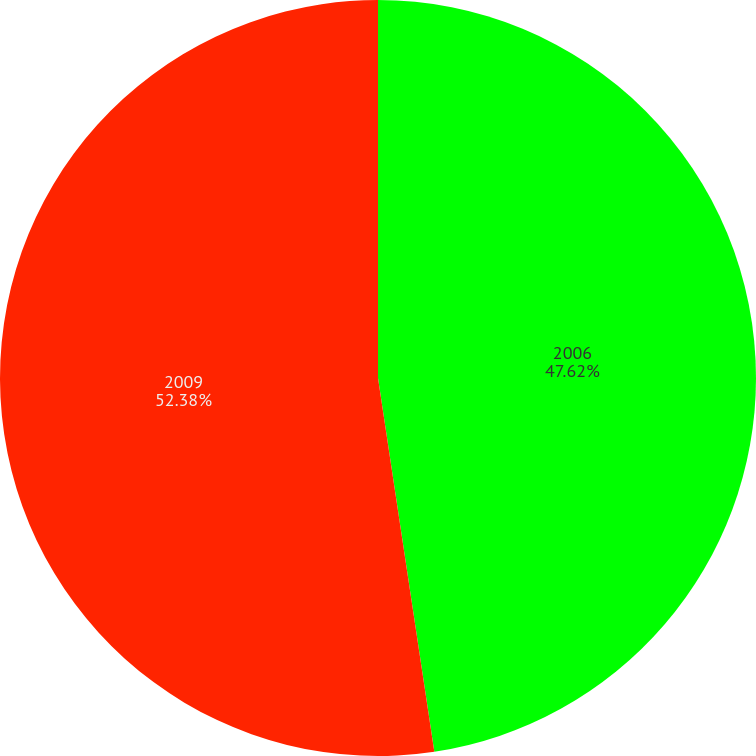Convert chart. <chart><loc_0><loc_0><loc_500><loc_500><pie_chart><fcel>2006<fcel>2009<nl><fcel>47.62%<fcel>52.38%<nl></chart> 